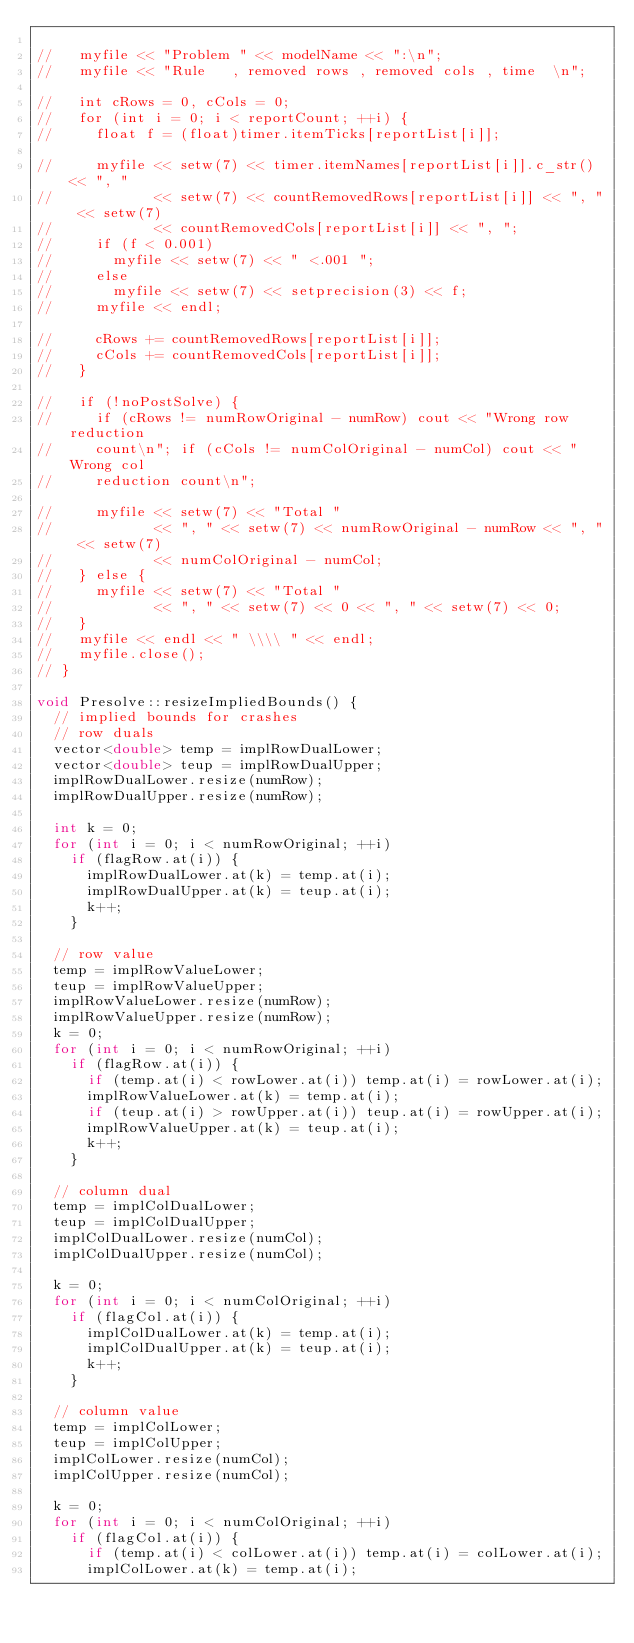Convert code to text. <code><loc_0><loc_0><loc_500><loc_500><_C++_>
//   myfile << "Problem " << modelName << ":\n";
//   myfile << "Rule   , removed rows , removed cols , time  \n";

//   int cRows = 0, cCols = 0;
//   for (int i = 0; i < reportCount; ++i) {
//     float f = (float)timer.itemTicks[reportList[i]];

//     myfile << setw(7) << timer.itemNames[reportList[i]].c_str() << ", "
//            << setw(7) << countRemovedRows[reportList[i]] << ", " << setw(7)
//            << countRemovedCols[reportList[i]] << ", ";
//     if (f < 0.001)
//       myfile << setw(7) << " <.001 ";
//     else
//       myfile << setw(7) << setprecision(3) << f;
//     myfile << endl;

//     cRows += countRemovedRows[reportList[i]];
//     cCols += countRemovedCols[reportList[i]];
//   }

//   if (!noPostSolve) {
//     if (cRows != numRowOriginal - numRow) cout << "Wrong row reduction
//     count\n"; if (cCols != numColOriginal - numCol) cout << "Wrong col
//     reduction count\n";

//     myfile << setw(7) << "Total "
//            << ", " << setw(7) << numRowOriginal - numRow << ", " << setw(7)
//            << numColOriginal - numCol;
//   } else {
//     myfile << setw(7) << "Total "
//            << ", " << setw(7) << 0 << ", " << setw(7) << 0;
//   }
//   myfile << endl << " \\\\ " << endl;
//   myfile.close();
// }

void Presolve::resizeImpliedBounds() {
  // implied bounds for crashes
  // row duals
  vector<double> temp = implRowDualLower;
  vector<double> teup = implRowDualUpper;
  implRowDualLower.resize(numRow);
  implRowDualUpper.resize(numRow);

  int k = 0;
  for (int i = 0; i < numRowOriginal; ++i)
    if (flagRow.at(i)) {
      implRowDualLower.at(k) = temp.at(i);
      implRowDualUpper.at(k) = teup.at(i);
      k++;
    }

  // row value
  temp = implRowValueLower;
  teup = implRowValueUpper;
  implRowValueLower.resize(numRow);
  implRowValueUpper.resize(numRow);
  k = 0;
  for (int i = 0; i < numRowOriginal; ++i)
    if (flagRow.at(i)) {
      if (temp.at(i) < rowLower.at(i)) temp.at(i) = rowLower.at(i);
      implRowValueLower.at(k) = temp.at(i);
      if (teup.at(i) > rowUpper.at(i)) teup.at(i) = rowUpper.at(i);
      implRowValueUpper.at(k) = teup.at(i);
      k++;
    }

  // column dual
  temp = implColDualLower;
  teup = implColDualUpper;
  implColDualLower.resize(numCol);
  implColDualUpper.resize(numCol);

  k = 0;
  for (int i = 0; i < numColOriginal; ++i)
    if (flagCol.at(i)) {
      implColDualLower.at(k) = temp.at(i);
      implColDualUpper.at(k) = teup.at(i);
      k++;
    }

  // column value
  temp = implColLower;
  teup = implColUpper;
  implColLower.resize(numCol);
  implColUpper.resize(numCol);

  k = 0;
  for (int i = 0; i < numColOriginal; ++i)
    if (flagCol.at(i)) {
      if (temp.at(i) < colLower.at(i)) temp.at(i) = colLower.at(i);
      implColLower.at(k) = temp.at(i);</code> 